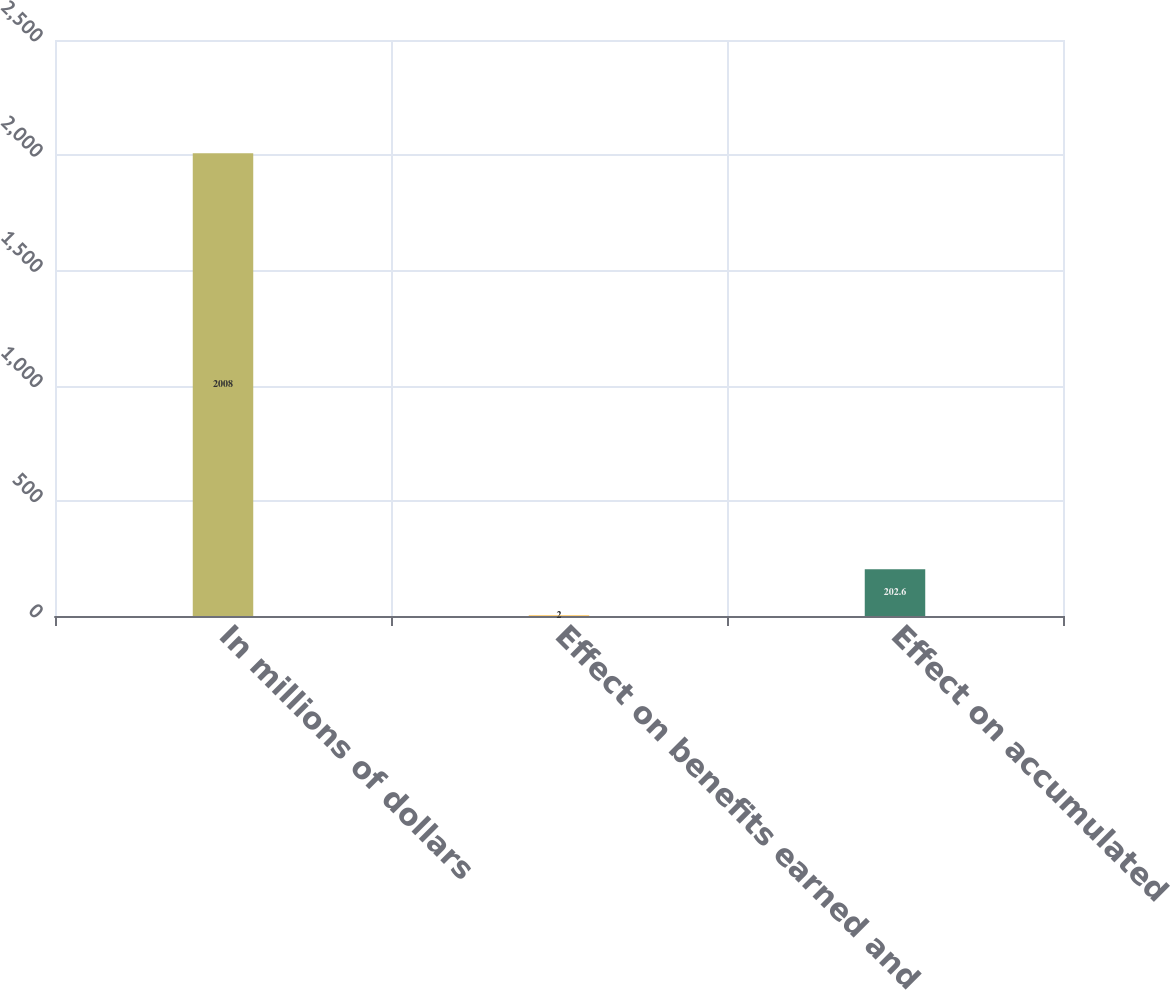Convert chart to OTSL. <chart><loc_0><loc_0><loc_500><loc_500><bar_chart><fcel>In millions of dollars<fcel>Effect on benefits earned and<fcel>Effect on accumulated<nl><fcel>2008<fcel>2<fcel>202.6<nl></chart> 